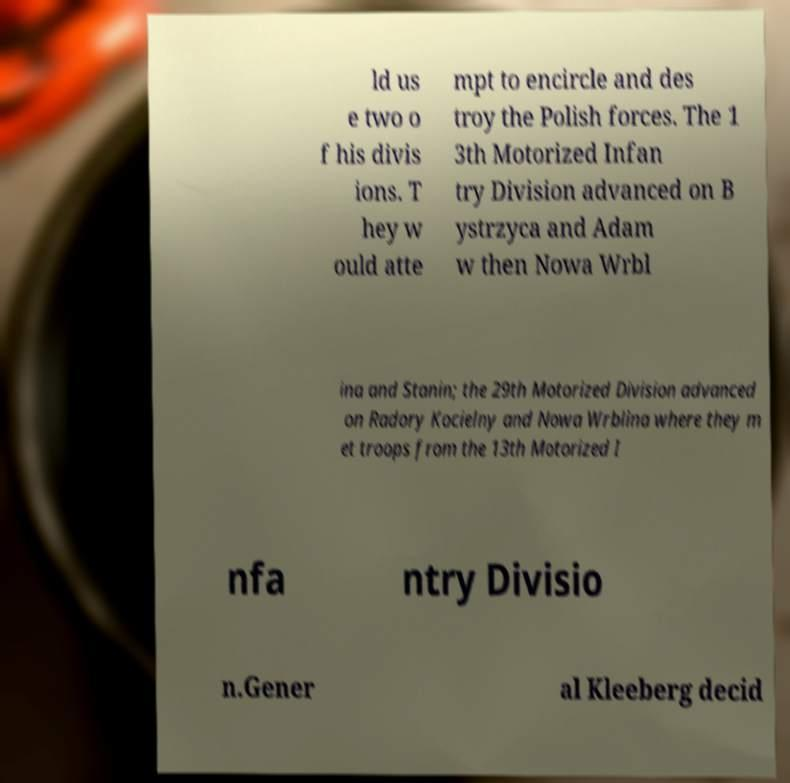Can you read and provide the text displayed in the image?This photo seems to have some interesting text. Can you extract and type it out for me? ld us e two o f his divis ions. T hey w ould atte mpt to encircle and des troy the Polish forces. The 1 3th Motorized Infan try Division advanced on B ystrzyca and Adam w then Nowa Wrbl ina and Stanin; the 29th Motorized Division advanced on Radory Kocielny and Nowa Wrblina where they m et troops from the 13th Motorized I nfa ntry Divisio n.Gener al Kleeberg decid 